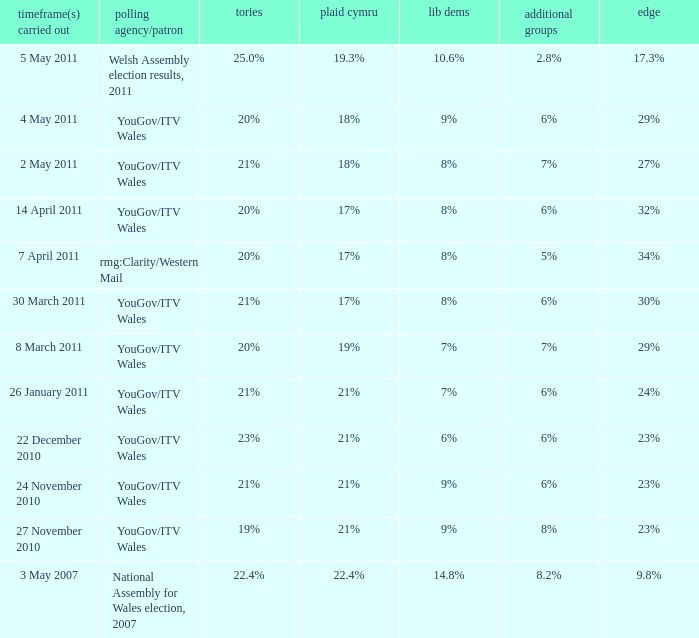I want the lead for others being 5% 34%. 